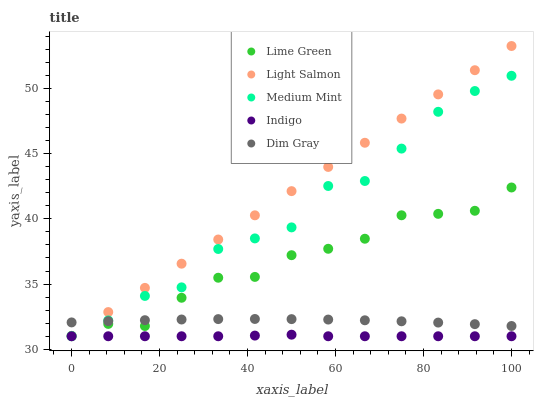Does Indigo have the minimum area under the curve?
Answer yes or no. Yes. Does Light Salmon have the maximum area under the curve?
Answer yes or no. Yes. Does Light Salmon have the minimum area under the curve?
Answer yes or no. No. Does Indigo have the maximum area under the curve?
Answer yes or no. No. Is Light Salmon the smoothest?
Answer yes or no. Yes. Is Medium Mint the roughest?
Answer yes or no. Yes. Is Indigo the smoothest?
Answer yes or no. No. Is Indigo the roughest?
Answer yes or no. No. Does Medium Mint have the lowest value?
Answer yes or no. Yes. Does Dim Gray have the lowest value?
Answer yes or no. No. Does Light Salmon have the highest value?
Answer yes or no. Yes. Does Indigo have the highest value?
Answer yes or no. No. Is Indigo less than Lime Green?
Answer yes or no. Yes. Is Lime Green greater than Indigo?
Answer yes or no. Yes. Does Indigo intersect Medium Mint?
Answer yes or no. Yes. Is Indigo less than Medium Mint?
Answer yes or no. No. Is Indigo greater than Medium Mint?
Answer yes or no. No. Does Indigo intersect Lime Green?
Answer yes or no. No. 